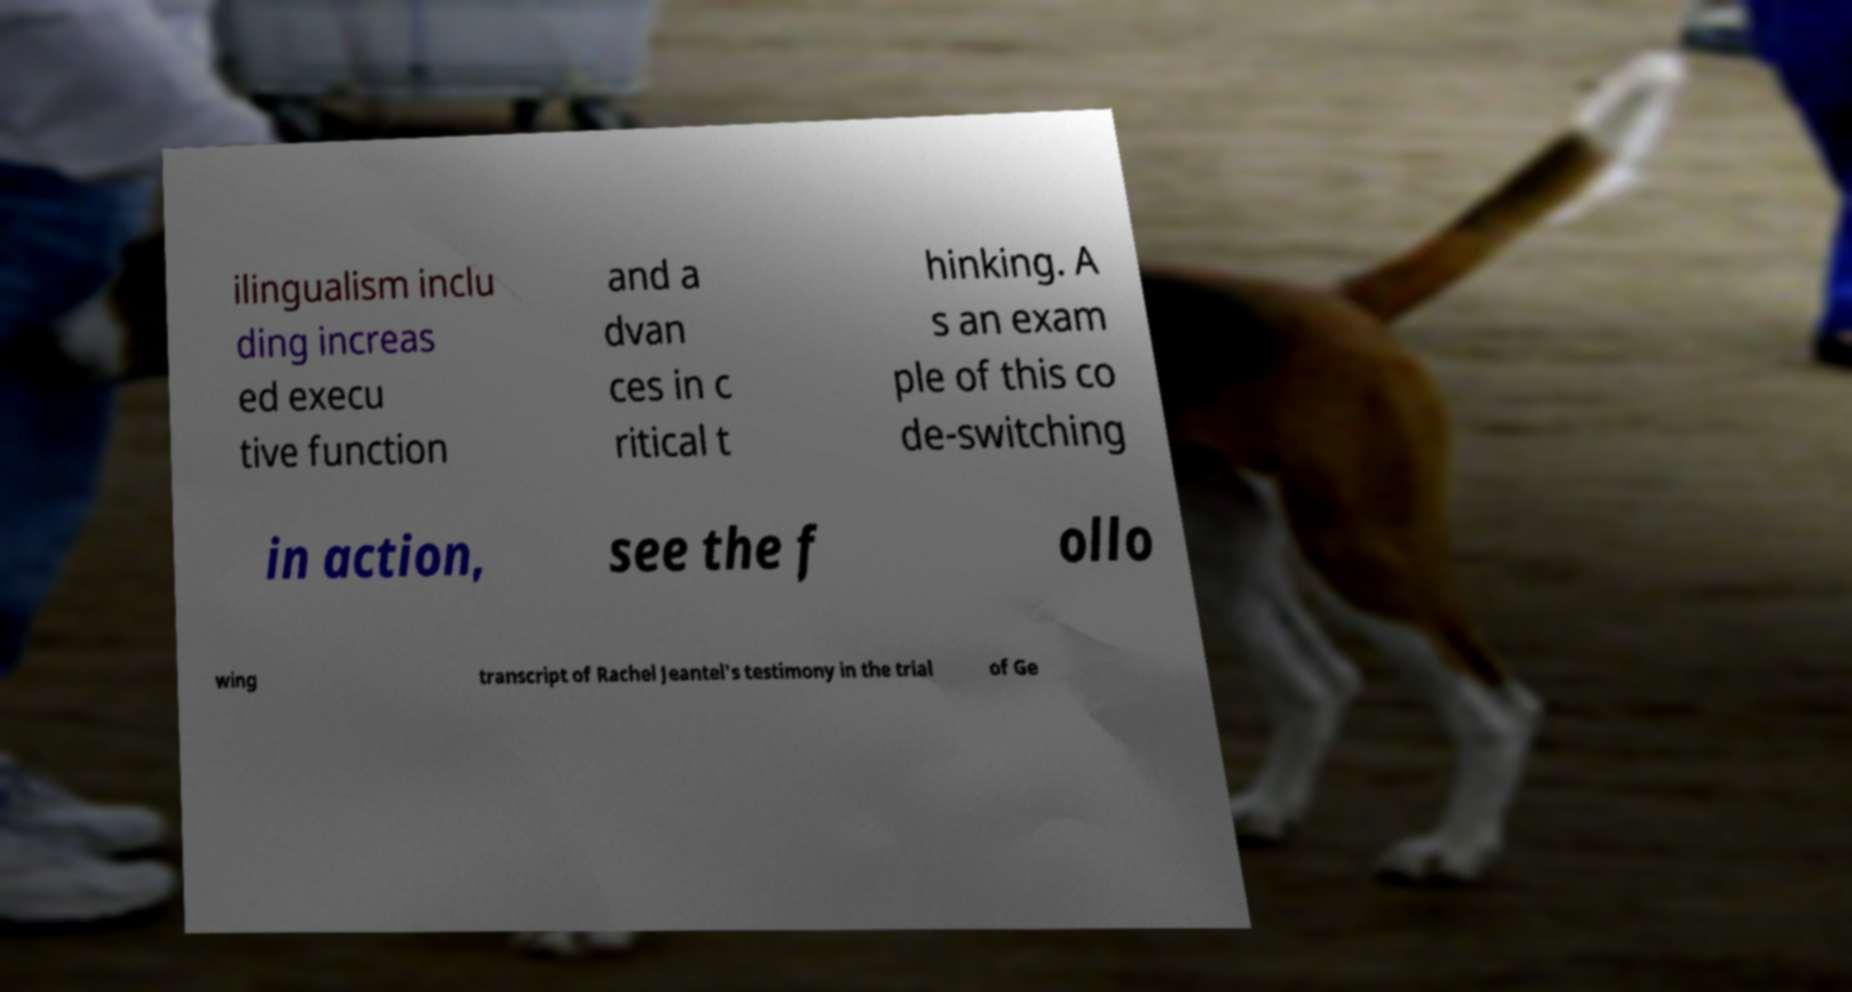There's text embedded in this image that I need extracted. Can you transcribe it verbatim? ilingualism inclu ding increas ed execu tive function and a dvan ces in c ritical t hinking. A s an exam ple of this co de-switching in action, see the f ollo wing transcript of Rachel Jeantel's testimony in the trial of Ge 